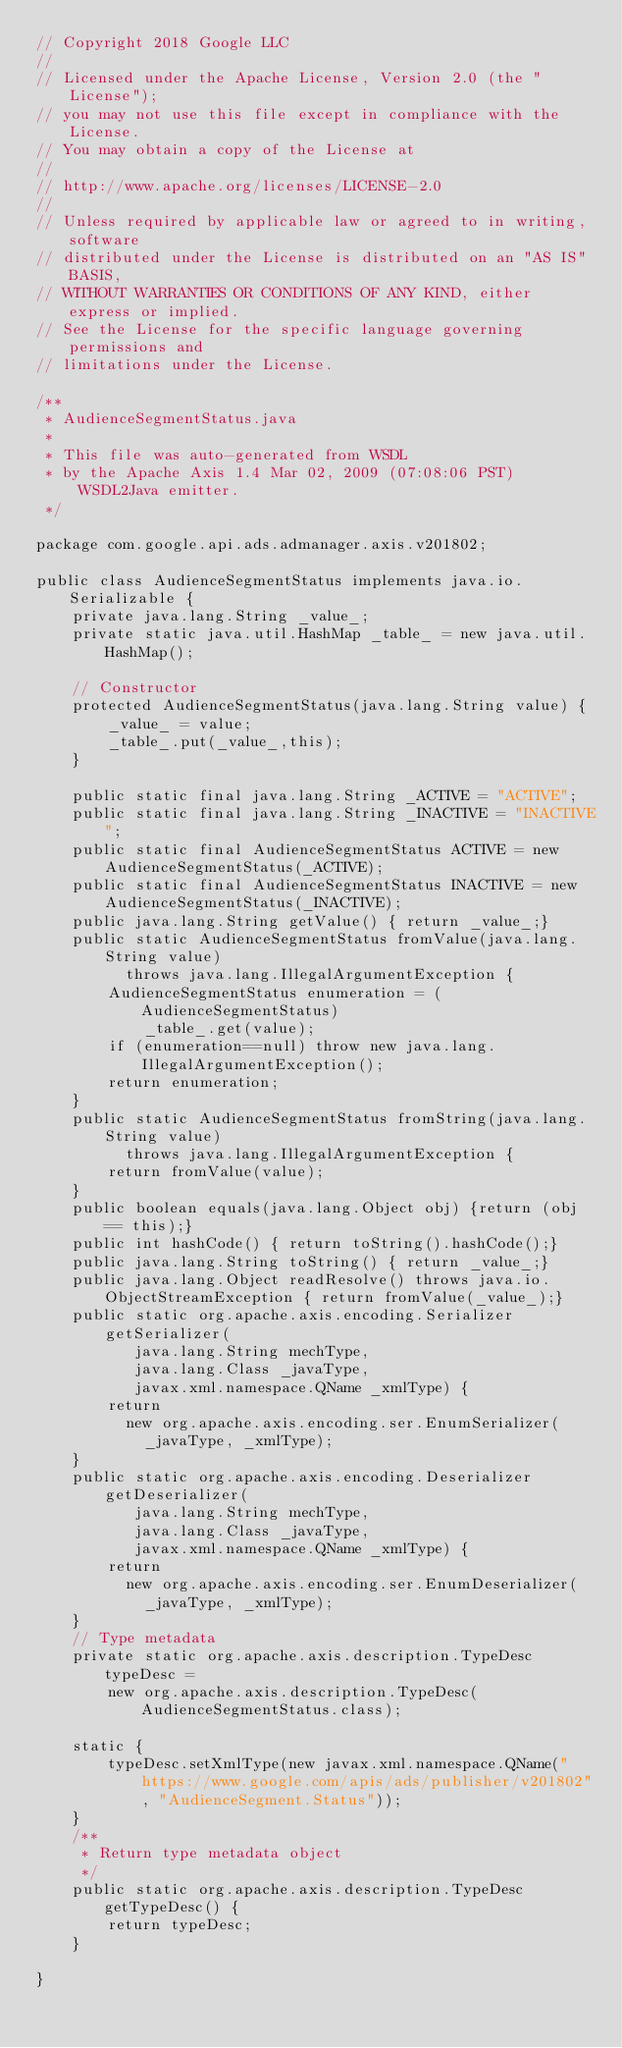Convert code to text. <code><loc_0><loc_0><loc_500><loc_500><_Java_>// Copyright 2018 Google LLC
//
// Licensed under the Apache License, Version 2.0 (the "License");
// you may not use this file except in compliance with the License.
// You may obtain a copy of the License at
//
// http://www.apache.org/licenses/LICENSE-2.0
//
// Unless required by applicable law or agreed to in writing, software
// distributed under the License is distributed on an "AS IS" BASIS,
// WITHOUT WARRANTIES OR CONDITIONS OF ANY KIND, either express or implied.
// See the License for the specific language governing permissions and
// limitations under the License.

/**
 * AudienceSegmentStatus.java
 *
 * This file was auto-generated from WSDL
 * by the Apache Axis 1.4 Mar 02, 2009 (07:08:06 PST) WSDL2Java emitter.
 */

package com.google.api.ads.admanager.axis.v201802;

public class AudienceSegmentStatus implements java.io.Serializable {
    private java.lang.String _value_;
    private static java.util.HashMap _table_ = new java.util.HashMap();

    // Constructor
    protected AudienceSegmentStatus(java.lang.String value) {
        _value_ = value;
        _table_.put(_value_,this);
    }

    public static final java.lang.String _ACTIVE = "ACTIVE";
    public static final java.lang.String _INACTIVE = "INACTIVE";
    public static final AudienceSegmentStatus ACTIVE = new AudienceSegmentStatus(_ACTIVE);
    public static final AudienceSegmentStatus INACTIVE = new AudienceSegmentStatus(_INACTIVE);
    public java.lang.String getValue() { return _value_;}
    public static AudienceSegmentStatus fromValue(java.lang.String value)
          throws java.lang.IllegalArgumentException {
        AudienceSegmentStatus enumeration = (AudienceSegmentStatus)
            _table_.get(value);
        if (enumeration==null) throw new java.lang.IllegalArgumentException();
        return enumeration;
    }
    public static AudienceSegmentStatus fromString(java.lang.String value)
          throws java.lang.IllegalArgumentException {
        return fromValue(value);
    }
    public boolean equals(java.lang.Object obj) {return (obj == this);}
    public int hashCode() { return toString().hashCode();}
    public java.lang.String toString() { return _value_;}
    public java.lang.Object readResolve() throws java.io.ObjectStreamException { return fromValue(_value_);}
    public static org.apache.axis.encoding.Serializer getSerializer(
           java.lang.String mechType, 
           java.lang.Class _javaType,  
           javax.xml.namespace.QName _xmlType) {
        return 
          new org.apache.axis.encoding.ser.EnumSerializer(
            _javaType, _xmlType);
    }
    public static org.apache.axis.encoding.Deserializer getDeserializer(
           java.lang.String mechType, 
           java.lang.Class _javaType,  
           javax.xml.namespace.QName _xmlType) {
        return 
          new org.apache.axis.encoding.ser.EnumDeserializer(
            _javaType, _xmlType);
    }
    // Type metadata
    private static org.apache.axis.description.TypeDesc typeDesc =
        new org.apache.axis.description.TypeDesc(AudienceSegmentStatus.class);

    static {
        typeDesc.setXmlType(new javax.xml.namespace.QName("https://www.google.com/apis/ads/publisher/v201802", "AudienceSegment.Status"));
    }
    /**
     * Return type metadata object
     */
    public static org.apache.axis.description.TypeDesc getTypeDesc() {
        return typeDesc;
    }

}
</code> 